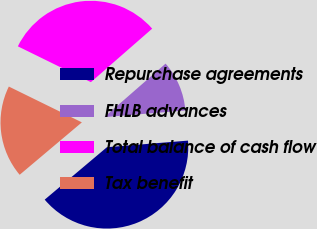Convert chart to OTSL. <chart><loc_0><loc_0><loc_500><loc_500><pie_chart><fcel>Repurchase agreements<fcel>FHLB advances<fcel>Total balance of cash flow<fcel>Tax benefit<nl><fcel>40.15%<fcel>10.13%<fcel>31.32%<fcel>18.4%<nl></chart> 